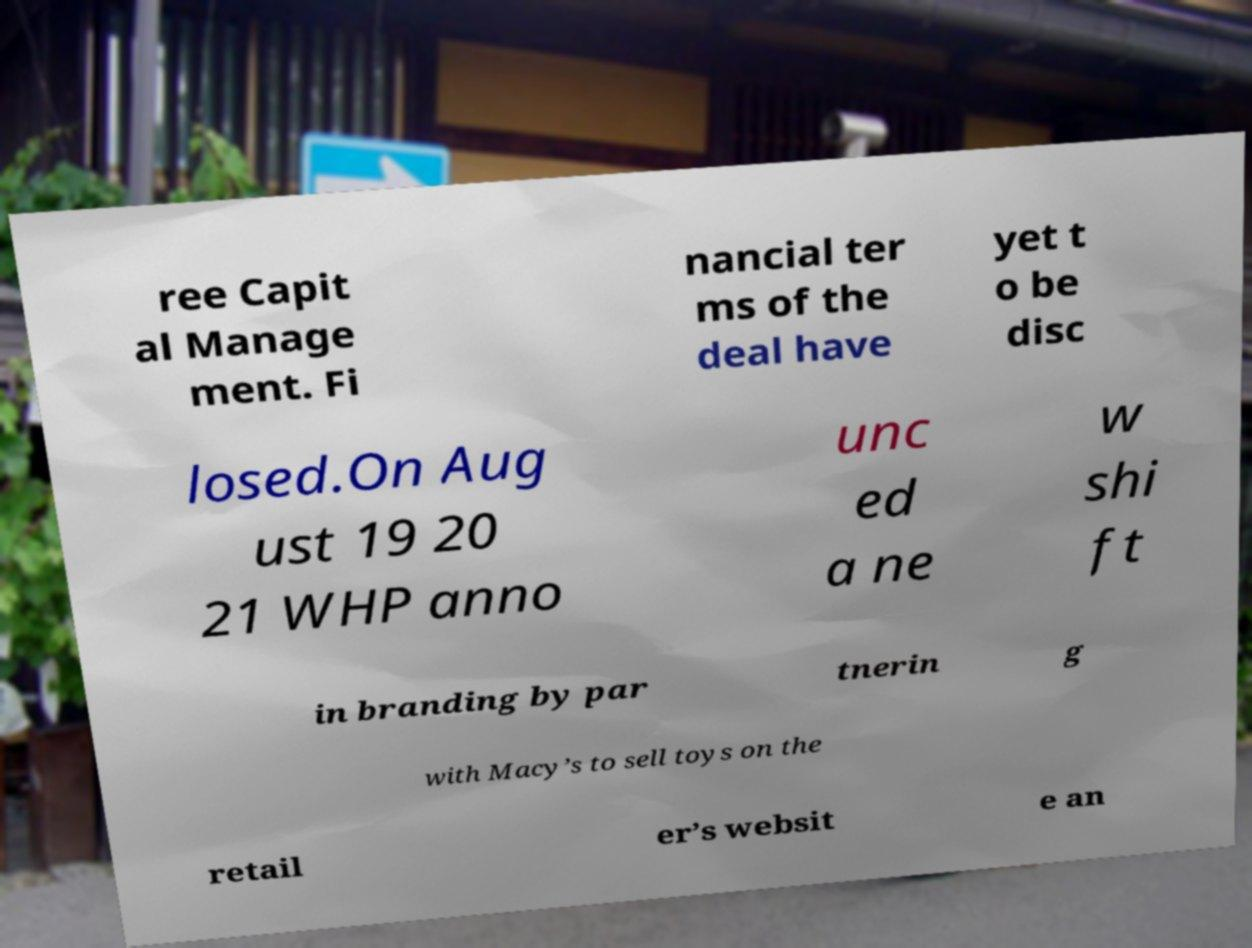I need the written content from this picture converted into text. Can you do that? ree Capit al Manage ment. Fi nancial ter ms of the deal have yet t o be disc losed.On Aug ust 19 20 21 WHP anno unc ed a ne w shi ft in branding by par tnerin g with Macy’s to sell toys on the retail er’s websit e an 